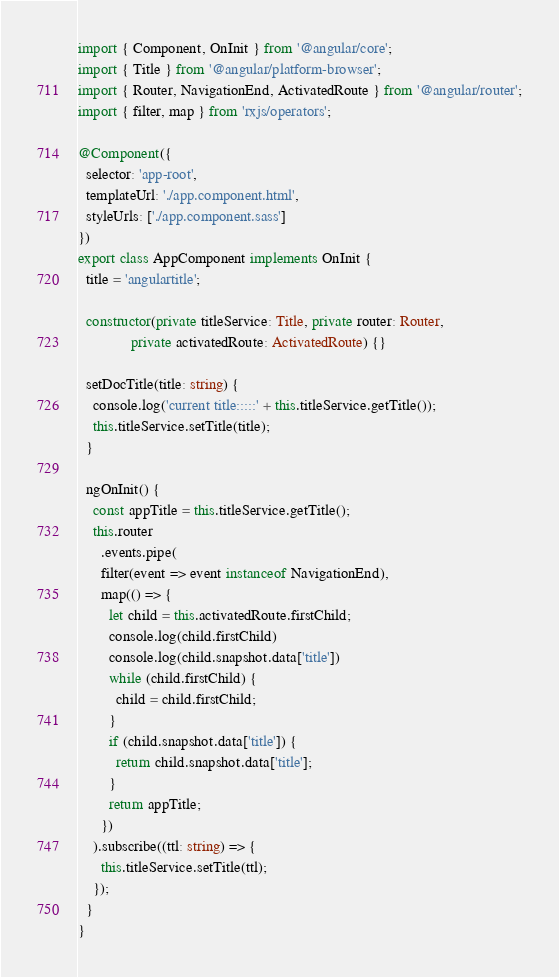<code> <loc_0><loc_0><loc_500><loc_500><_TypeScript_>import { Component, OnInit } from '@angular/core';
import { Title } from '@angular/platform-browser';
import { Router, NavigationEnd, ActivatedRoute } from '@angular/router';
import { filter, map } from 'rxjs/operators';

@Component({
  selector: 'app-root',
  templateUrl: './app.component.html',
  styleUrls: ['./app.component.sass']
})
export class AppComponent implements OnInit {
  title = 'angulartitle';

  constructor(private titleService: Title, private router: Router,
              private activatedRoute: ActivatedRoute) {}

  setDocTitle(title: string) {
    console.log('current title:::::' + this.titleService.getTitle());
    this.titleService.setTitle(title);
  }

  ngOnInit() {
    const appTitle = this.titleService.getTitle();
    this.router
      .events.pipe(
      filter(event => event instanceof NavigationEnd),
      map(() => {
        let child = this.activatedRoute.firstChild;
        console.log(child.firstChild)
        console.log(child.snapshot.data['title'])
        while (child.firstChild) {
          child = child.firstChild;
        }
        if (child.snapshot.data['title']) {
          return child.snapshot.data['title'];
        }
        return appTitle;
      })
    ).subscribe((ttl: string) => {
      this.titleService.setTitle(ttl);
    });
  }
}
</code> 